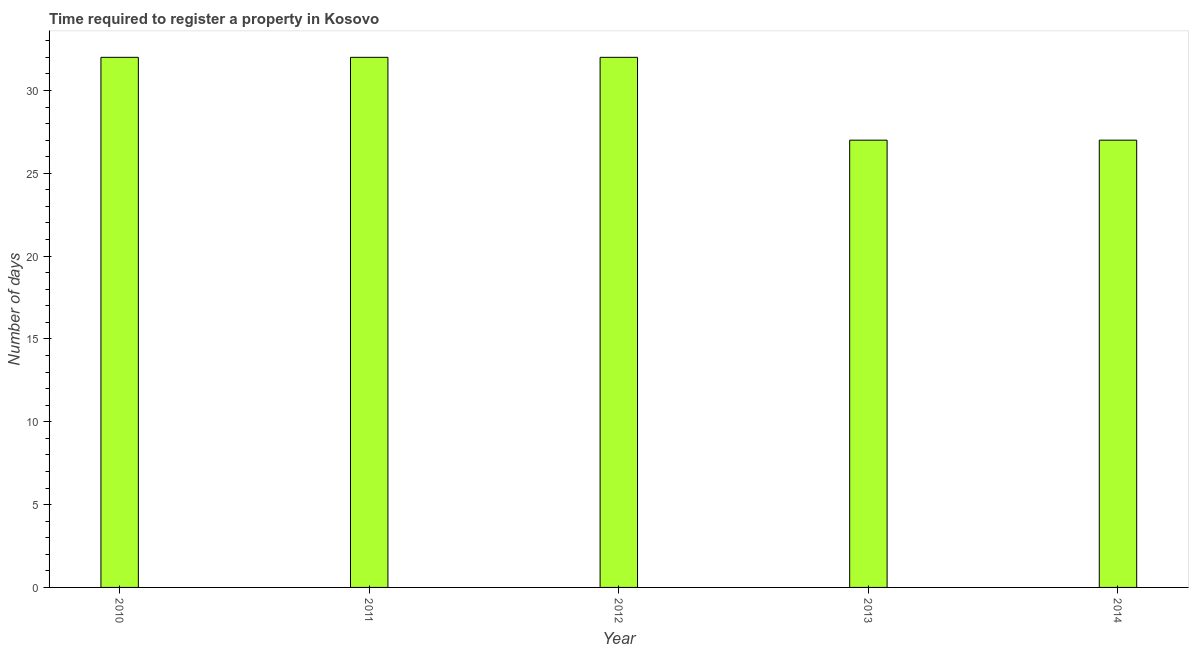Does the graph contain any zero values?
Give a very brief answer. No. Does the graph contain grids?
Your answer should be very brief. No. What is the title of the graph?
Your answer should be compact. Time required to register a property in Kosovo. What is the label or title of the X-axis?
Ensure brevity in your answer.  Year. What is the label or title of the Y-axis?
Give a very brief answer. Number of days. What is the sum of the number of days required to register property?
Offer a very short reply. 150. What is the difference between the number of days required to register property in 2012 and 2013?
Offer a very short reply. 5. What is the median number of days required to register property?
Your response must be concise. 32. Do a majority of the years between 2011 and 2010 (inclusive) have number of days required to register property greater than 30 days?
Make the answer very short. No. What is the ratio of the number of days required to register property in 2011 to that in 2014?
Your answer should be very brief. 1.19. Is the number of days required to register property in 2011 less than that in 2014?
Make the answer very short. No. Is the sum of the number of days required to register property in 2011 and 2012 greater than the maximum number of days required to register property across all years?
Ensure brevity in your answer.  Yes. What is the difference between two consecutive major ticks on the Y-axis?
Provide a succinct answer. 5. What is the Number of days of 2011?
Your response must be concise. 32. What is the Number of days in 2012?
Provide a short and direct response. 32. What is the Number of days in 2013?
Your response must be concise. 27. What is the Number of days of 2014?
Provide a short and direct response. 27. What is the difference between the Number of days in 2010 and 2011?
Ensure brevity in your answer.  0. What is the difference between the Number of days in 2010 and 2012?
Offer a very short reply. 0. What is the difference between the Number of days in 2010 and 2014?
Keep it short and to the point. 5. What is the difference between the Number of days in 2011 and 2012?
Your answer should be very brief. 0. What is the difference between the Number of days in 2011 and 2014?
Make the answer very short. 5. What is the difference between the Number of days in 2012 and 2014?
Provide a short and direct response. 5. What is the difference between the Number of days in 2013 and 2014?
Provide a short and direct response. 0. What is the ratio of the Number of days in 2010 to that in 2012?
Make the answer very short. 1. What is the ratio of the Number of days in 2010 to that in 2013?
Offer a terse response. 1.19. What is the ratio of the Number of days in 2010 to that in 2014?
Provide a succinct answer. 1.19. What is the ratio of the Number of days in 2011 to that in 2012?
Your answer should be compact. 1. What is the ratio of the Number of days in 2011 to that in 2013?
Offer a terse response. 1.19. What is the ratio of the Number of days in 2011 to that in 2014?
Provide a succinct answer. 1.19. What is the ratio of the Number of days in 2012 to that in 2013?
Your answer should be very brief. 1.19. What is the ratio of the Number of days in 2012 to that in 2014?
Your response must be concise. 1.19. What is the ratio of the Number of days in 2013 to that in 2014?
Offer a terse response. 1. 